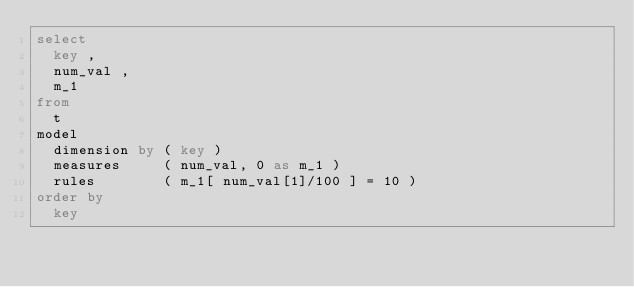<code> <loc_0><loc_0><loc_500><loc_500><_SQL_>select
  key ,
  num_val ,
  m_1
from
  t
model
  dimension by ( key )
  measures     ( num_val, 0 as m_1 )
  rules        ( m_1[ num_val[1]/100 ] = 10 )
order by
  key
</code> 